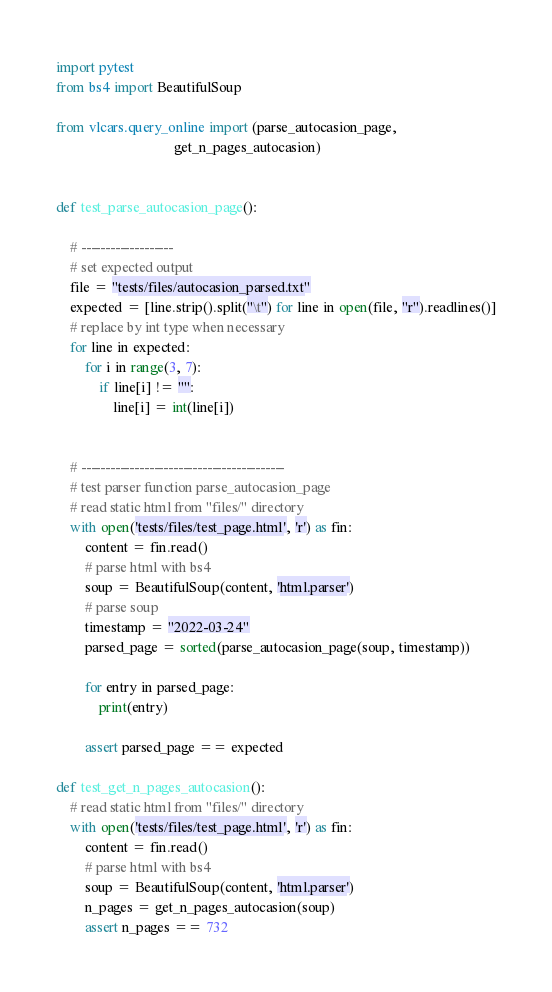Convert code to text. <code><loc_0><loc_0><loc_500><loc_500><_Python_>import pytest
from bs4 import BeautifulSoup

from vlcars.query_online import (parse_autocasion_page,
                                 get_n_pages_autocasion)


def test_parse_autocasion_page():

    # -------------------
    # set expected output
    file = "tests/files/autocasion_parsed.txt"
    expected = [line.strip().split("\t") for line in open(file, "r").readlines()]
    # replace by int type when necessary
    for line in expected:
        for i in range(3, 7):
            if line[i] != "":
                line[i] = int(line[i])


    # ------------------------------------------
    # test parser function parse_autocasion_page
    # read static html from "files/" directory
    with open('tests/files/test_page.html', 'r') as fin:
        content = fin.read()
        # parse html with bs4
        soup = BeautifulSoup(content, 'html.parser')
        # parse soup
        timestamp = "2022-03-24"
        parsed_page = sorted(parse_autocasion_page(soup, timestamp))

        for entry in parsed_page:
            print(entry)

        assert parsed_page == expected

def test_get_n_pages_autocasion():
    # read static html from "files/" directory
    with open('tests/files/test_page.html', 'r') as fin:
        content = fin.read()
        # parse html with bs4
        soup = BeautifulSoup(content, 'html.parser')
        n_pages = get_n_pages_autocasion(soup)
        assert n_pages == 732</code> 